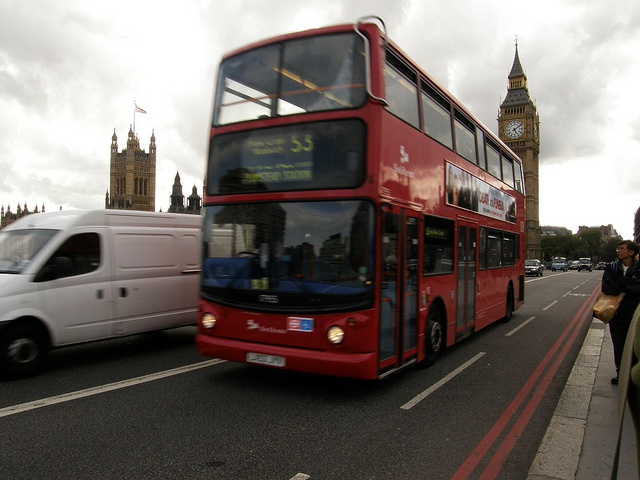Describe the objects in this image and their specific colors. I can see bus in lightgray, black, maroon, gray, and brown tones, truck in lightgray, gray, darkgray, and black tones, people in lightgray, black, maroon, and gray tones, handbag in lightgray, black, maroon, and gray tones, and clock in lightgray, gray, darkgray, olive, and black tones in this image. 